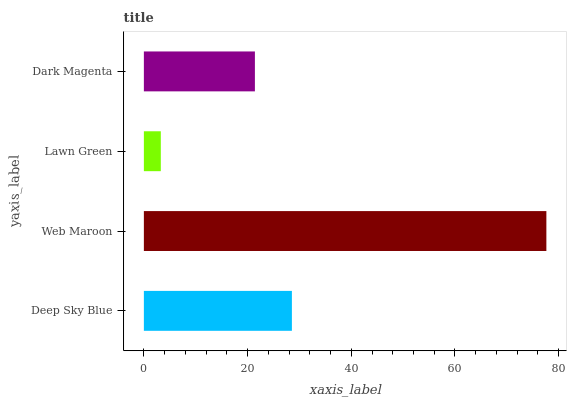Is Lawn Green the minimum?
Answer yes or no. Yes. Is Web Maroon the maximum?
Answer yes or no. Yes. Is Web Maroon the minimum?
Answer yes or no. No. Is Lawn Green the maximum?
Answer yes or no. No. Is Web Maroon greater than Lawn Green?
Answer yes or no. Yes. Is Lawn Green less than Web Maroon?
Answer yes or no. Yes. Is Lawn Green greater than Web Maroon?
Answer yes or no. No. Is Web Maroon less than Lawn Green?
Answer yes or no. No. Is Deep Sky Blue the high median?
Answer yes or no. Yes. Is Dark Magenta the low median?
Answer yes or no. Yes. Is Lawn Green the high median?
Answer yes or no. No. Is Deep Sky Blue the low median?
Answer yes or no. No. 